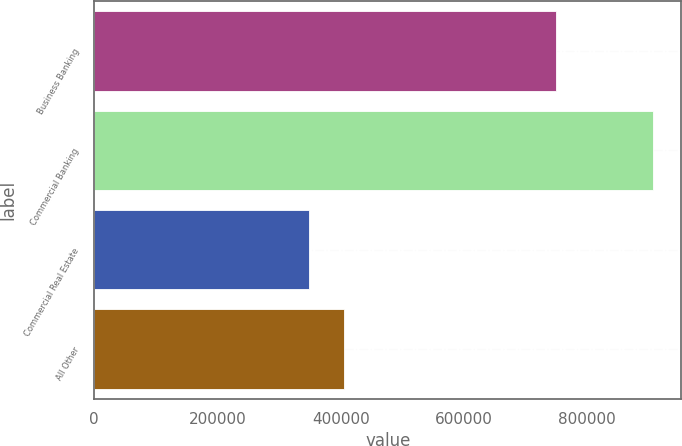Convert chart to OTSL. <chart><loc_0><loc_0><loc_500><loc_500><bar_chart><fcel>Business Banking<fcel>Commercial Banking<fcel>Commercial Real Estate<fcel>All Other<nl><fcel>748907<fcel>907524<fcel>349197<fcel>405030<nl></chart> 